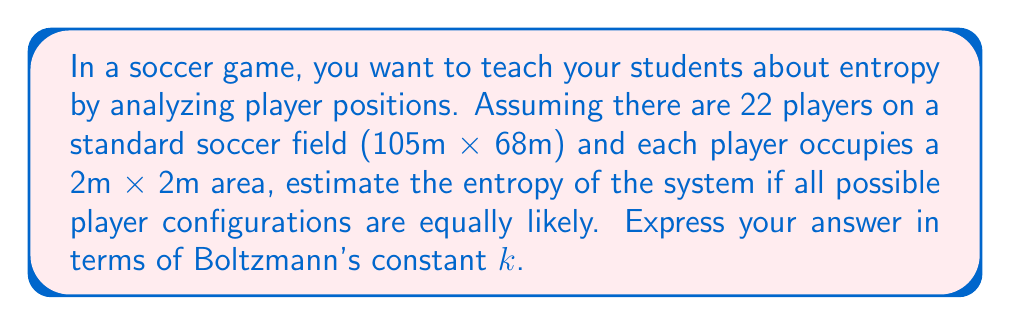Show me your answer to this math problem. Let's approach this step-by-step:

1) First, we need to calculate the number of possible microstates (W). This is the number of ways to arrange 22 players on the field.

2) The total area of the field is:
   $$ A_{total} = 105m \times 68m = 7140m^2 $$

3) Each player occupies a 2m x 2m area:
   $$ A_{player} = 2m \times 2m = 4m^2 $$

4) The number of possible positions for each player is:
   $$ N = \frac{A_{total}}{A_{player}} = \frac{7140m^2}{4m^2} = 1785 $$

5) We need to choose 22 positions out of these 1785 possible positions. This is a combination problem:
   $$ W = \binom{1785}{22} = \frac{1785!}{22!(1785-22)!} $$

6) This number is extremely large and difficult to calculate exactly. We can use Stirling's approximation:
   $$ \ln(n!) \approx n\ln(n) - n $$

7) Applying this to our combination:
   $$ \ln W \approx 1785\ln(1785) - 1785 - [22\ln(22) - 22 + 1763\ln(1763) - 1763] $$
   $$ \ln W \approx 195.4 $$

8) The entropy is given by Boltzmann's formula:
   $$ S = k \ln W $$

9) Therefore, the entropy is approximately:
   $$ S \approx 195.4k $$

Where k is Boltzmann's constant.
Answer: $195.4k$ 